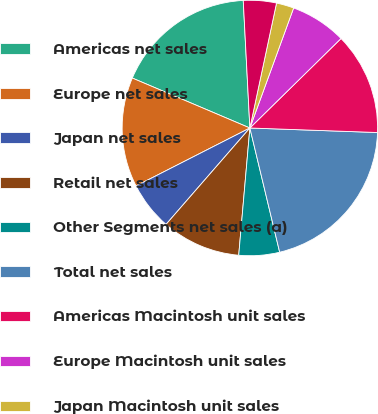Convert chart. <chart><loc_0><loc_0><loc_500><loc_500><pie_chart><fcel>Americas net sales<fcel>Europe net sales<fcel>Japan net sales<fcel>Retail net sales<fcel>Other Segments net sales (a)<fcel>Total net sales<fcel>Americas Macintosh unit sales<fcel>Europe Macintosh unit sales<fcel>Japan Macintosh unit sales<fcel>Retail Macintosh unit sales<nl><fcel>17.78%<fcel>13.89%<fcel>6.11%<fcel>10.0%<fcel>5.14%<fcel>20.69%<fcel>12.92%<fcel>7.08%<fcel>2.22%<fcel>4.17%<nl></chart> 